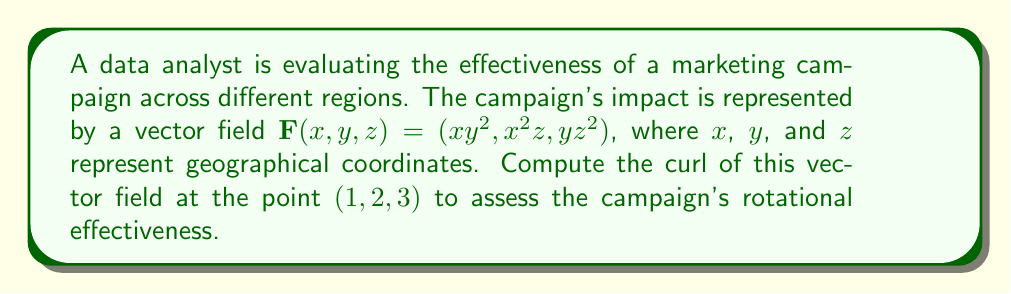Give your solution to this math problem. To compute the curl of the vector field, we need to follow these steps:

1) The curl of a vector field $\mathbf{F}(x,y,z) = (F_1, F_2, F_3)$ is defined as:

   $$\text{curl }\mathbf{F} = \nabla \times \mathbf{F} = \left(\frac{\partial F_3}{\partial y} - \frac{\partial F_2}{\partial z}, \frac{\partial F_1}{\partial z} - \frac{\partial F_3}{\partial x}, \frac{\partial F_2}{\partial x} - \frac{\partial F_1}{\partial y}\right)$$

2) For our vector field $\mathbf{F}(x,y,z) = (xy^2, x^2z, yz^2)$, we have:
   $F_1 = xy^2$
   $F_2 = x^2z$
   $F_3 = yz^2$

3) Let's compute each component of the curl:

   a) $\frac{\partial F_3}{\partial y} - \frac{\partial F_2}{\partial z}$:
      $\frac{\partial F_3}{\partial y} = z^2$
      $\frac{\partial F_2}{\partial z} = x^2$
      First component: $z^2 - x^2$

   b) $\frac{\partial F_1}{\partial z} - \frac{\partial F_3}{\partial x}$:
      $\frac{\partial F_1}{\partial z} = 0$
      $\frac{\partial F_3}{\partial x} = 0$
      Second component: $0 - 0 = 0$

   c) $\frac{\partial F_2}{\partial x} - \frac{\partial F_1}{\partial y}$:
      $\frac{\partial F_2}{\partial x} = 2xz$
      $\frac{\partial F_1}{\partial y} = 2xy$
      Third component: $2xz - 2xy$

4) Therefore, the curl of $\mathbf{F}$ is:
   $$\text{curl }\mathbf{F} = (z^2 - x^2, 0, 2xz - 2xy)$$

5) At the point $(1,2,3)$, we evaluate:
   $z^2 - x^2 = 3^2 - 1^2 = 8$
   $0 = 0$
   $2xz - 2xy = 2(1)(3) - 2(1)(2) = 2$

Thus, the curl at $(1,2,3)$ is $(8, 0, 2)$.
Answer: $(8, 0, 2)$ 